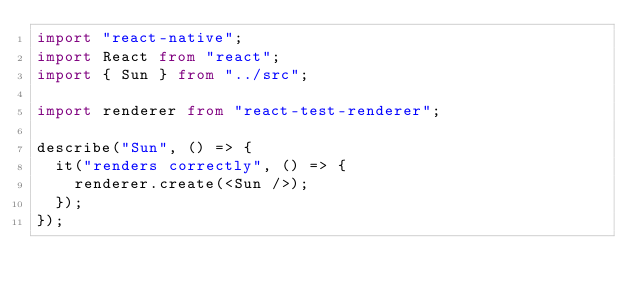Convert code to text. <code><loc_0><loc_0><loc_500><loc_500><_TypeScript_>import "react-native";
import React from "react";
import { Sun } from "../src";

import renderer from "react-test-renderer";

describe("Sun", () => {
  it("renders correctly", () => {
    renderer.create(<Sun />);
  });
});
</code> 